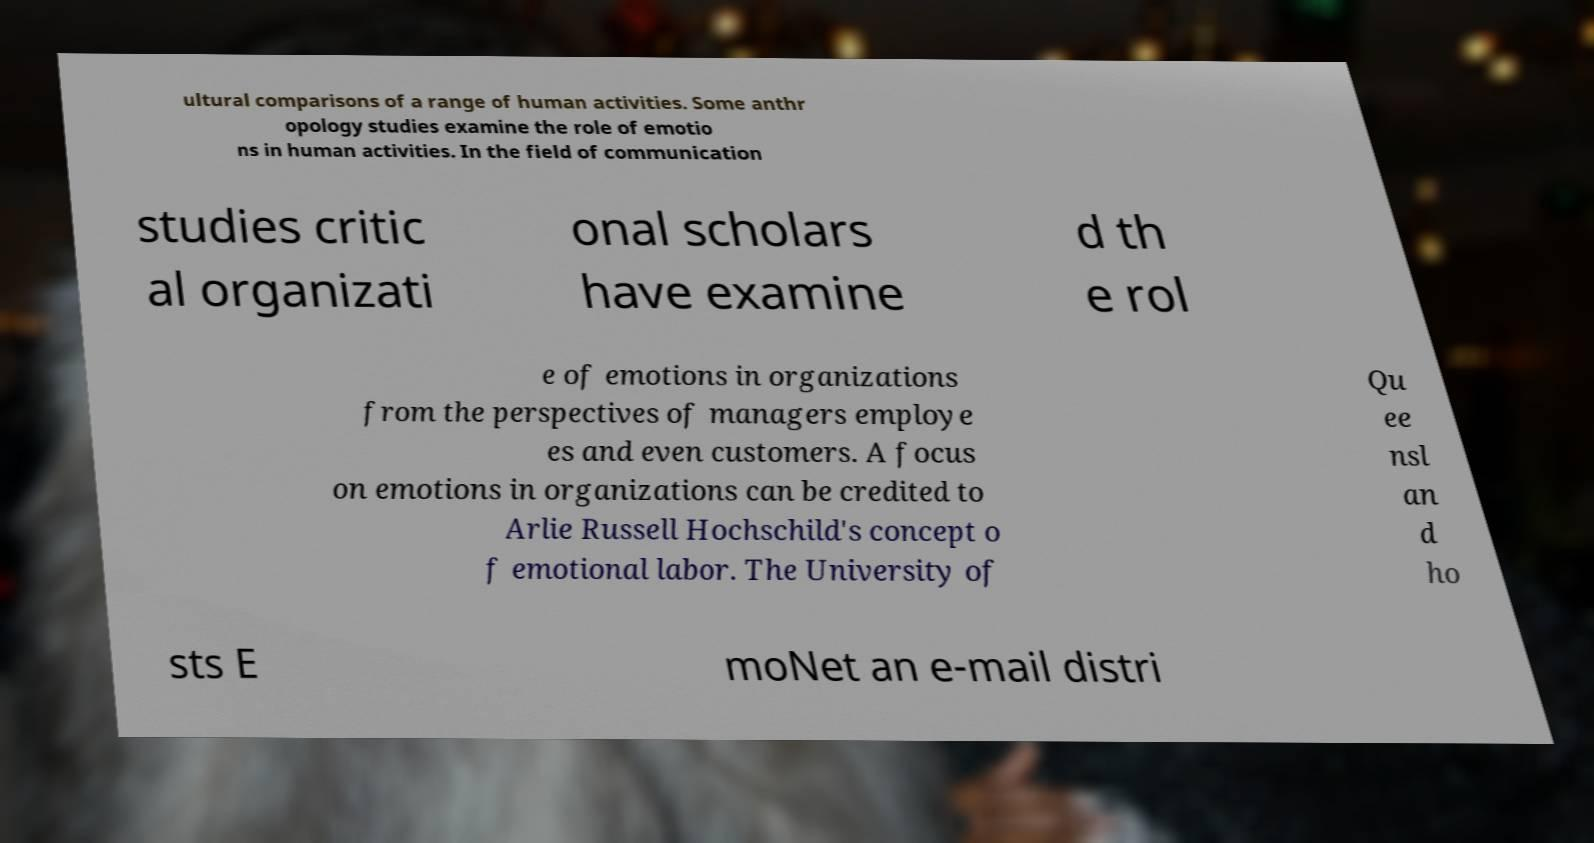Please identify and transcribe the text found in this image. ultural comparisons of a range of human activities. Some anthr opology studies examine the role of emotio ns in human activities. In the field of communication studies critic al organizati onal scholars have examine d th e rol e of emotions in organizations from the perspectives of managers employe es and even customers. A focus on emotions in organizations can be credited to Arlie Russell Hochschild's concept o f emotional labor. The University of Qu ee nsl an d ho sts E moNet an e-mail distri 